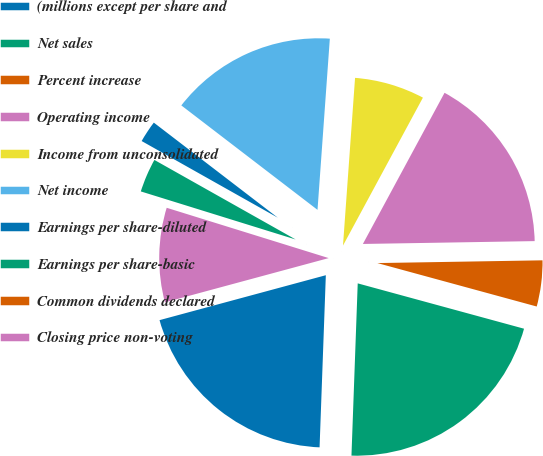Convert chart. <chart><loc_0><loc_0><loc_500><loc_500><pie_chart><fcel>(millions except per share and<fcel>Net sales<fcel>Percent increase<fcel>Operating income<fcel>Income from unconsolidated<fcel>Net income<fcel>Earnings per share-diluted<fcel>Earnings per share-basic<fcel>Common dividends declared<fcel>Closing price non-voting<nl><fcel>20.22%<fcel>21.34%<fcel>4.5%<fcel>16.85%<fcel>6.74%<fcel>15.73%<fcel>2.25%<fcel>3.37%<fcel>0.0%<fcel>8.99%<nl></chart> 